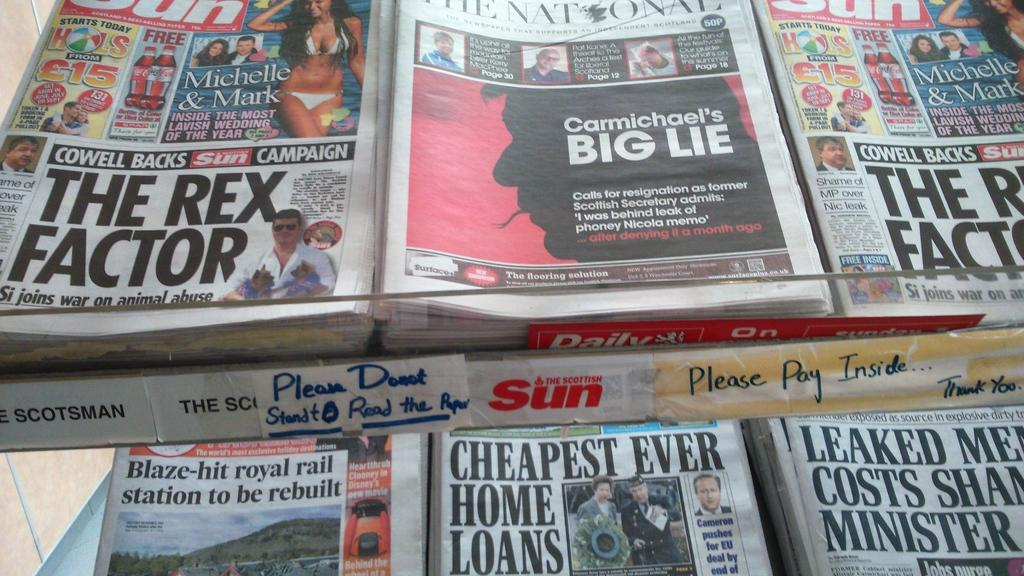<image>
Create a compact narrative representing the image presented. Several copies of newspapers, including The Sun and The National. 